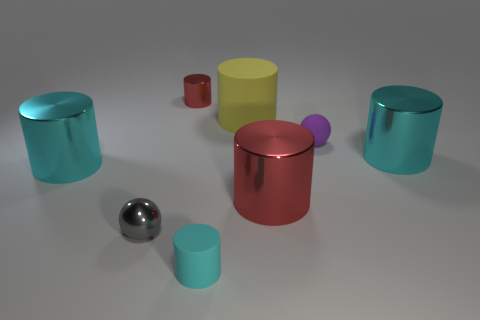How many cyan cylinders must be subtracted to get 1 cyan cylinders? 2 Subtract all blue balls. How many cyan cylinders are left? 3 Subtract 2 cylinders. How many cylinders are left? 4 Subtract all yellow cylinders. How many cylinders are left? 5 Subtract all cyan matte cylinders. How many cylinders are left? 5 Subtract all brown cylinders. Subtract all blue cubes. How many cylinders are left? 6 Add 1 tiny red objects. How many objects exist? 9 Subtract all cylinders. How many objects are left? 2 Add 8 tiny metal balls. How many tiny metal balls are left? 9 Add 8 yellow cylinders. How many yellow cylinders exist? 9 